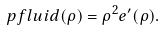Convert formula to latex. <formula><loc_0><loc_0><loc_500><loc_500>\ p f l u i d ( \rho ) = \rho ^ { 2 } e ^ { \prime } ( \rho ) .</formula> 